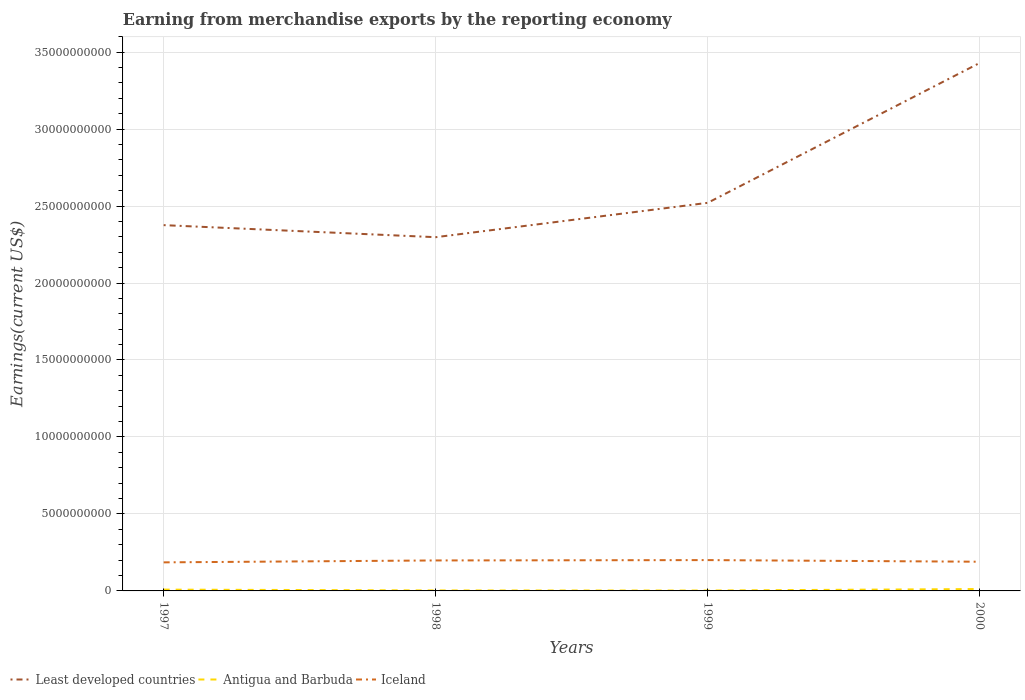Is the number of lines equal to the number of legend labels?
Make the answer very short. Yes. Across all years, what is the maximum amount earned from merchandise exports in Least developed countries?
Your answer should be very brief. 2.30e+1. What is the total amount earned from merchandise exports in Least developed countries in the graph?
Offer a very short reply. -1.13e+1. What is the difference between the highest and the second highest amount earned from merchandise exports in Iceland?
Keep it short and to the point. 1.47e+08. How many lines are there?
Offer a very short reply. 3. How many years are there in the graph?
Your answer should be compact. 4. What is the difference between two consecutive major ticks on the Y-axis?
Make the answer very short. 5.00e+09. Does the graph contain any zero values?
Your answer should be very brief. No. Does the graph contain grids?
Ensure brevity in your answer.  Yes. How are the legend labels stacked?
Provide a short and direct response. Horizontal. What is the title of the graph?
Provide a short and direct response. Earning from merchandise exports by the reporting economy. Does "Sub-Saharan Africa (all income levels)" appear as one of the legend labels in the graph?
Your answer should be very brief. No. What is the label or title of the Y-axis?
Offer a very short reply. Earnings(current US$). What is the Earnings(current US$) in Least developed countries in 1997?
Give a very brief answer. 2.38e+1. What is the Earnings(current US$) of Antigua and Barbuda in 1997?
Ensure brevity in your answer.  8.50e+07. What is the Earnings(current US$) of Iceland in 1997?
Your response must be concise. 1.86e+09. What is the Earnings(current US$) in Least developed countries in 1998?
Make the answer very short. 2.30e+1. What is the Earnings(current US$) in Antigua and Barbuda in 1998?
Offer a terse response. 3.19e+07. What is the Earnings(current US$) of Iceland in 1998?
Give a very brief answer. 1.98e+09. What is the Earnings(current US$) of Least developed countries in 1999?
Your answer should be very brief. 2.52e+1. What is the Earnings(current US$) in Antigua and Barbuda in 1999?
Your answer should be compact. 2.60e+07. What is the Earnings(current US$) in Iceland in 1999?
Your response must be concise. 2.00e+09. What is the Earnings(current US$) in Least developed countries in 2000?
Your answer should be compact. 3.43e+1. What is the Earnings(current US$) in Antigua and Barbuda in 2000?
Your answer should be very brief. 1.23e+08. What is the Earnings(current US$) of Iceland in 2000?
Offer a terse response. 1.90e+09. Across all years, what is the maximum Earnings(current US$) in Least developed countries?
Make the answer very short. 3.43e+1. Across all years, what is the maximum Earnings(current US$) in Antigua and Barbuda?
Provide a succinct answer. 1.23e+08. Across all years, what is the maximum Earnings(current US$) in Iceland?
Offer a terse response. 2.00e+09. Across all years, what is the minimum Earnings(current US$) of Least developed countries?
Your answer should be compact. 2.30e+1. Across all years, what is the minimum Earnings(current US$) in Antigua and Barbuda?
Keep it short and to the point. 2.60e+07. Across all years, what is the minimum Earnings(current US$) of Iceland?
Offer a terse response. 1.86e+09. What is the total Earnings(current US$) of Least developed countries in the graph?
Provide a succinct answer. 1.06e+11. What is the total Earnings(current US$) in Antigua and Barbuda in the graph?
Your response must be concise. 2.65e+08. What is the total Earnings(current US$) of Iceland in the graph?
Keep it short and to the point. 7.73e+09. What is the difference between the Earnings(current US$) of Least developed countries in 1997 and that in 1998?
Your answer should be very brief. 7.83e+08. What is the difference between the Earnings(current US$) in Antigua and Barbuda in 1997 and that in 1998?
Offer a terse response. 5.31e+07. What is the difference between the Earnings(current US$) in Iceland in 1997 and that in 1998?
Ensure brevity in your answer.  -1.24e+08. What is the difference between the Earnings(current US$) in Least developed countries in 1997 and that in 1999?
Provide a short and direct response. -1.45e+09. What is the difference between the Earnings(current US$) of Antigua and Barbuda in 1997 and that in 1999?
Provide a succinct answer. 5.90e+07. What is the difference between the Earnings(current US$) in Iceland in 1997 and that in 1999?
Provide a succinct answer. -1.47e+08. What is the difference between the Earnings(current US$) of Least developed countries in 1997 and that in 2000?
Make the answer very short. -1.05e+1. What is the difference between the Earnings(current US$) in Antigua and Barbuda in 1997 and that in 2000?
Ensure brevity in your answer.  -3.76e+07. What is the difference between the Earnings(current US$) of Iceland in 1997 and that in 2000?
Your answer should be compact. -4.10e+07. What is the difference between the Earnings(current US$) of Least developed countries in 1998 and that in 1999?
Provide a short and direct response. -2.23e+09. What is the difference between the Earnings(current US$) in Antigua and Barbuda in 1998 and that in 1999?
Keep it short and to the point. 5.89e+06. What is the difference between the Earnings(current US$) in Iceland in 1998 and that in 1999?
Give a very brief answer. -2.29e+07. What is the difference between the Earnings(current US$) of Least developed countries in 1998 and that in 2000?
Provide a succinct answer. -1.13e+1. What is the difference between the Earnings(current US$) in Antigua and Barbuda in 1998 and that in 2000?
Give a very brief answer. -9.07e+07. What is the difference between the Earnings(current US$) of Iceland in 1998 and that in 2000?
Keep it short and to the point. 8.31e+07. What is the difference between the Earnings(current US$) in Least developed countries in 1999 and that in 2000?
Your answer should be very brief. -9.09e+09. What is the difference between the Earnings(current US$) of Antigua and Barbuda in 1999 and that in 2000?
Your answer should be compact. -9.66e+07. What is the difference between the Earnings(current US$) in Iceland in 1999 and that in 2000?
Make the answer very short. 1.06e+08. What is the difference between the Earnings(current US$) in Least developed countries in 1997 and the Earnings(current US$) in Antigua and Barbuda in 1998?
Ensure brevity in your answer.  2.37e+1. What is the difference between the Earnings(current US$) in Least developed countries in 1997 and the Earnings(current US$) in Iceland in 1998?
Your answer should be very brief. 2.18e+1. What is the difference between the Earnings(current US$) in Antigua and Barbuda in 1997 and the Earnings(current US$) in Iceland in 1998?
Offer a very short reply. -1.89e+09. What is the difference between the Earnings(current US$) of Least developed countries in 1997 and the Earnings(current US$) of Antigua and Barbuda in 1999?
Your answer should be compact. 2.37e+1. What is the difference between the Earnings(current US$) in Least developed countries in 1997 and the Earnings(current US$) in Iceland in 1999?
Give a very brief answer. 2.18e+1. What is the difference between the Earnings(current US$) of Antigua and Barbuda in 1997 and the Earnings(current US$) of Iceland in 1999?
Ensure brevity in your answer.  -1.92e+09. What is the difference between the Earnings(current US$) of Least developed countries in 1997 and the Earnings(current US$) of Antigua and Barbuda in 2000?
Your response must be concise. 2.36e+1. What is the difference between the Earnings(current US$) in Least developed countries in 1997 and the Earnings(current US$) in Iceland in 2000?
Provide a succinct answer. 2.19e+1. What is the difference between the Earnings(current US$) in Antigua and Barbuda in 1997 and the Earnings(current US$) in Iceland in 2000?
Your answer should be very brief. -1.81e+09. What is the difference between the Earnings(current US$) of Least developed countries in 1998 and the Earnings(current US$) of Antigua and Barbuda in 1999?
Offer a very short reply. 2.30e+1. What is the difference between the Earnings(current US$) of Least developed countries in 1998 and the Earnings(current US$) of Iceland in 1999?
Your answer should be very brief. 2.10e+1. What is the difference between the Earnings(current US$) of Antigua and Barbuda in 1998 and the Earnings(current US$) of Iceland in 1999?
Make the answer very short. -1.97e+09. What is the difference between the Earnings(current US$) in Least developed countries in 1998 and the Earnings(current US$) in Antigua and Barbuda in 2000?
Provide a succinct answer. 2.29e+1. What is the difference between the Earnings(current US$) of Least developed countries in 1998 and the Earnings(current US$) of Iceland in 2000?
Keep it short and to the point. 2.11e+1. What is the difference between the Earnings(current US$) in Antigua and Barbuda in 1998 and the Earnings(current US$) in Iceland in 2000?
Keep it short and to the point. -1.86e+09. What is the difference between the Earnings(current US$) in Least developed countries in 1999 and the Earnings(current US$) in Antigua and Barbuda in 2000?
Keep it short and to the point. 2.51e+1. What is the difference between the Earnings(current US$) in Least developed countries in 1999 and the Earnings(current US$) in Iceland in 2000?
Your answer should be very brief. 2.33e+1. What is the difference between the Earnings(current US$) of Antigua and Barbuda in 1999 and the Earnings(current US$) of Iceland in 2000?
Your response must be concise. -1.87e+09. What is the average Earnings(current US$) in Least developed countries per year?
Make the answer very short. 2.66e+1. What is the average Earnings(current US$) of Antigua and Barbuda per year?
Make the answer very short. 6.64e+07. What is the average Earnings(current US$) in Iceland per year?
Ensure brevity in your answer.  1.93e+09. In the year 1997, what is the difference between the Earnings(current US$) of Least developed countries and Earnings(current US$) of Antigua and Barbuda?
Your answer should be compact. 2.37e+1. In the year 1997, what is the difference between the Earnings(current US$) of Least developed countries and Earnings(current US$) of Iceland?
Your answer should be compact. 2.19e+1. In the year 1997, what is the difference between the Earnings(current US$) in Antigua and Barbuda and Earnings(current US$) in Iceland?
Provide a short and direct response. -1.77e+09. In the year 1998, what is the difference between the Earnings(current US$) of Least developed countries and Earnings(current US$) of Antigua and Barbuda?
Offer a terse response. 2.29e+1. In the year 1998, what is the difference between the Earnings(current US$) in Least developed countries and Earnings(current US$) in Iceland?
Offer a very short reply. 2.10e+1. In the year 1998, what is the difference between the Earnings(current US$) in Antigua and Barbuda and Earnings(current US$) in Iceland?
Provide a short and direct response. -1.95e+09. In the year 1999, what is the difference between the Earnings(current US$) of Least developed countries and Earnings(current US$) of Antigua and Barbuda?
Ensure brevity in your answer.  2.52e+1. In the year 1999, what is the difference between the Earnings(current US$) in Least developed countries and Earnings(current US$) in Iceland?
Keep it short and to the point. 2.32e+1. In the year 1999, what is the difference between the Earnings(current US$) in Antigua and Barbuda and Earnings(current US$) in Iceland?
Ensure brevity in your answer.  -1.98e+09. In the year 2000, what is the difference between the Earnings(current US$) of Least developed countries and Earnings(current US$) of Antigua and Barbuda?
Give a very brief answer. 3.42e+1. In the year 2000, what is the difference between the Earnings(current US$) of Least developed countries and Earnings(current US$) of Iceland?
Your answer should be compact. 3.24e+1. In the year 2000, what is the difference between the Earnings(current US$) of Antigua and Barbuda and Earnings(current US$) of Iceland?
Offer a terse response. -1.77e+09. What is the ratio of the Earnings(current US$) in Least developed countries in 1997 to that in 1998?
Your answer should be very brief. 1.03. What is the ratio of the Earnings(current US$) of Antigua and Barbuda in 1997 to that in 1998?
Make the answer very short. 2.67. What is the ratio of the Earnings(current US$) in Iceland in 1997 to that in 1998?
Your response must be concise. 0.94. What is the ratio of the Earnings(current US$) in Least developed countries in 1997 to that in 1999?
Keep it short and to the point. 0.94. What is the ratio of the Earnings(current US$) of Antigua and Barbuda in 1997 to that in 1999?
Provide a short and direct response. 3.27. What is the ratio of the Earnings(current US$) in Iceland in 1997 to that in 1999?
Make the answer very short. 0.93. What is the ratio of the Earnings(current US$) of Least developed countries in 1997 to that in 2000?
Offer a terse response. 0.69. What is the ratio of the Earnings(current US$) in Antigua and Barbuda in 1997 to that in 2000?
Offer a terse response. 0.69. What is the ratio of the Earnings(current US$) in Iceland in 1997 to that in 2000?
Your answer should be compact. 0.98. What is the ratio of the Earnings(current US$) in Least developed countries in 1998 to that in 1999?
Make the answer very short. 0.91. What is the ratio of the Earnings(current US$) of Antigua and Barbuda in 1998 to that in 1999?
Make the answer very short. 1.23. What is the ratio of the Earnings(current US$) of Iceland in 1998 to that in 1999?
Give a very brief answer. 0.99. What is the ratio of the Earnings(current US$) in Least developed countries in 1998 to that in 2000?
Your answer should be very brief. 0.67. What is the ratio of the Earnings(current US$) in Antigua and Barbuda in 1998 to that in 2000?
Make the answer very short. 0.26. What is the ratio of the Earnings(current US$) in Iceland in 1998 to that in 2000?
Your response must be concise. 1.04. What is the ratio of the Earnings(current US$) of Least developed countries in 1999 to that in 2000?
Provide a short and direct response. 0.74. What is the ratio of the Earnings(current US$) of Antigua and Barbuda in 1999 to that in 2000?
Your answer should be compact. 0.21. What is the ratio of the Earnings(current US$) of Iceland in 1999 to that in 2000?
Give a very brief answer. 1.06. What is the difference between the highest and the second highest Earnings(current US$) in Least developed countries?
Make the answer very short. 9.09e+09. What is the difference between the highest and the second highest Earnings(current US$) in Antigua and Barbuda?
Keep it short and to the point. 3.76e+07. What is the difference between the highest and the second highest Earnings(current US$) in Iceland?
Your answer should be very brief. 2.29e+07. What is the difference between the highest and the lowest Earnings(current US$) in Least developed countries?
Provide a succinct answer. 1.13e+1. What is the difference between the highest and the lowest Earnings(current US$) of Antigua and Barbuda?
Give a very brief answer. 9.66e+07. What is the difference between the highest and the lowest Earnings(current US$) of Iceland?
Offer a terse response. 1.47e+08. 